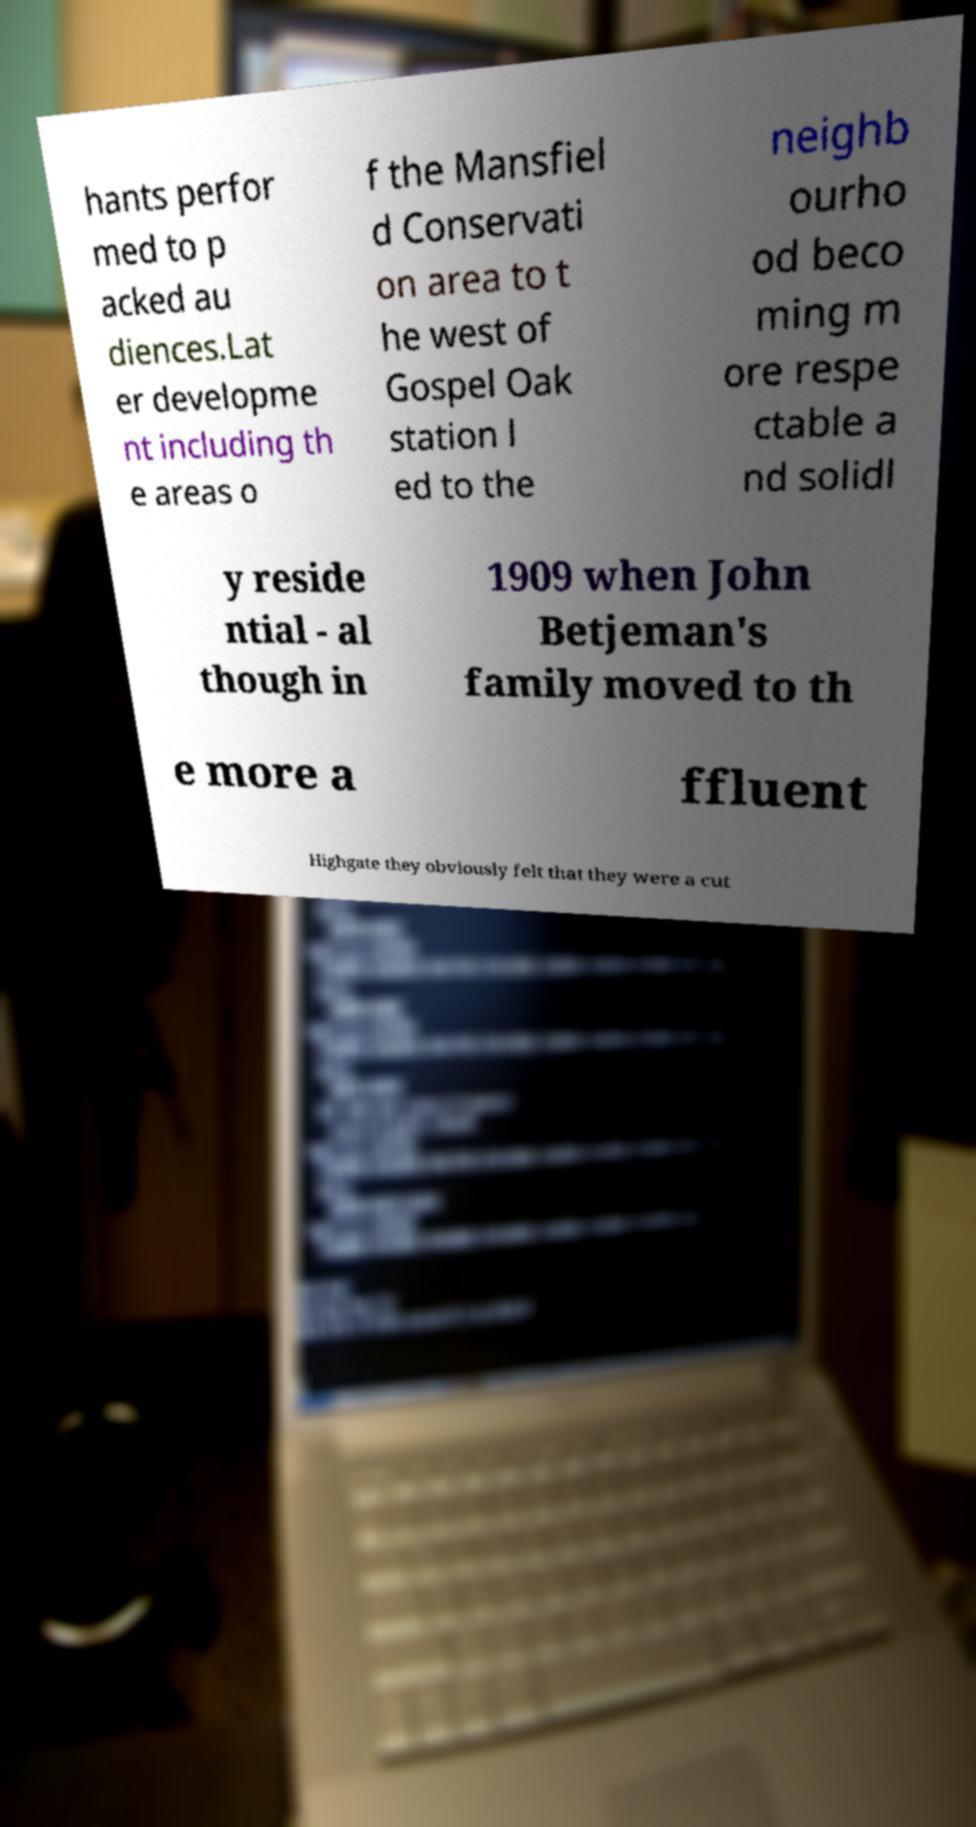Please read and relay the text visible in this image. What does it say? hants perfor med to p acked au diences.Lat er developme nt including th e areas o f the Mansfiel d Conservati on area to t he west of Gospel Oak station l ed to the neighb ourho od beco ming m ore respe ctable a nd solidl y reside ntial - al though in 1909 when John Betjeman's family moved to th e more a ffluent Highgate they obviously felt that they were a cut 